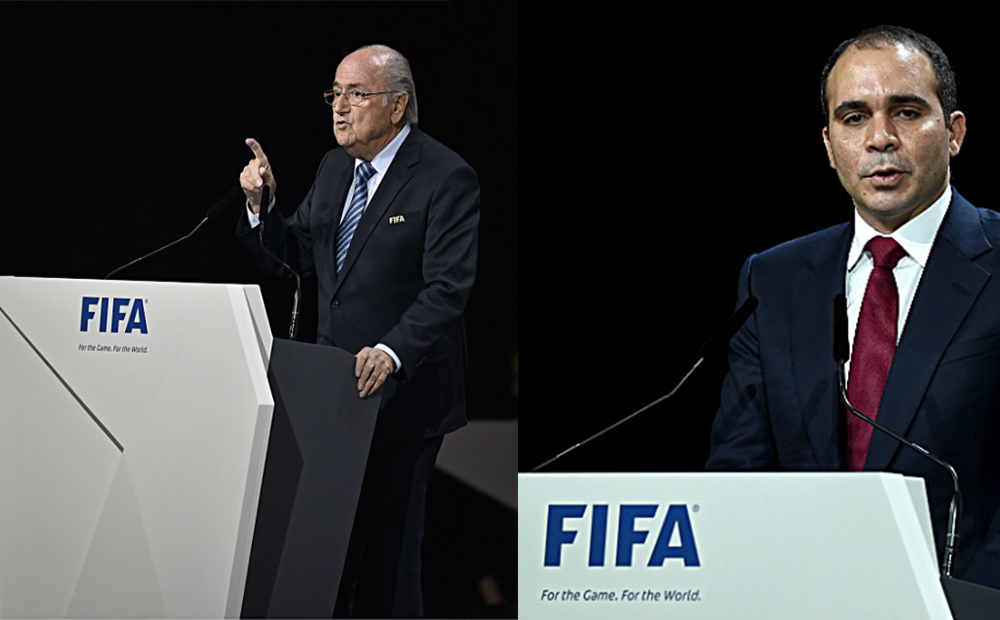Considering the context provided by the FIFA branding on the lecterns, what can be inferred about the roles or positions these two individuals might hold within the organization, and how might their attire and posture contribute to the perception of their authority and professionalism in such a setting? Based on the FIFA branding on the lecterns, it can be inferred that these individuals are likely to be officials or representatives of FIFA, possibly delivering speeches or reports at a FIFA event. Their formal attire, consisting of dark suits and ties, is consistent with the dress code for professionals in high-ranking positions, which contributes to the perception of their authority and professionalism. The older gentleman's assertive gesture and the younger man's serious expression both suggest confidence and the importance of their messages, reinforcing their authoritative presence in the context of a FIFA-related event. 